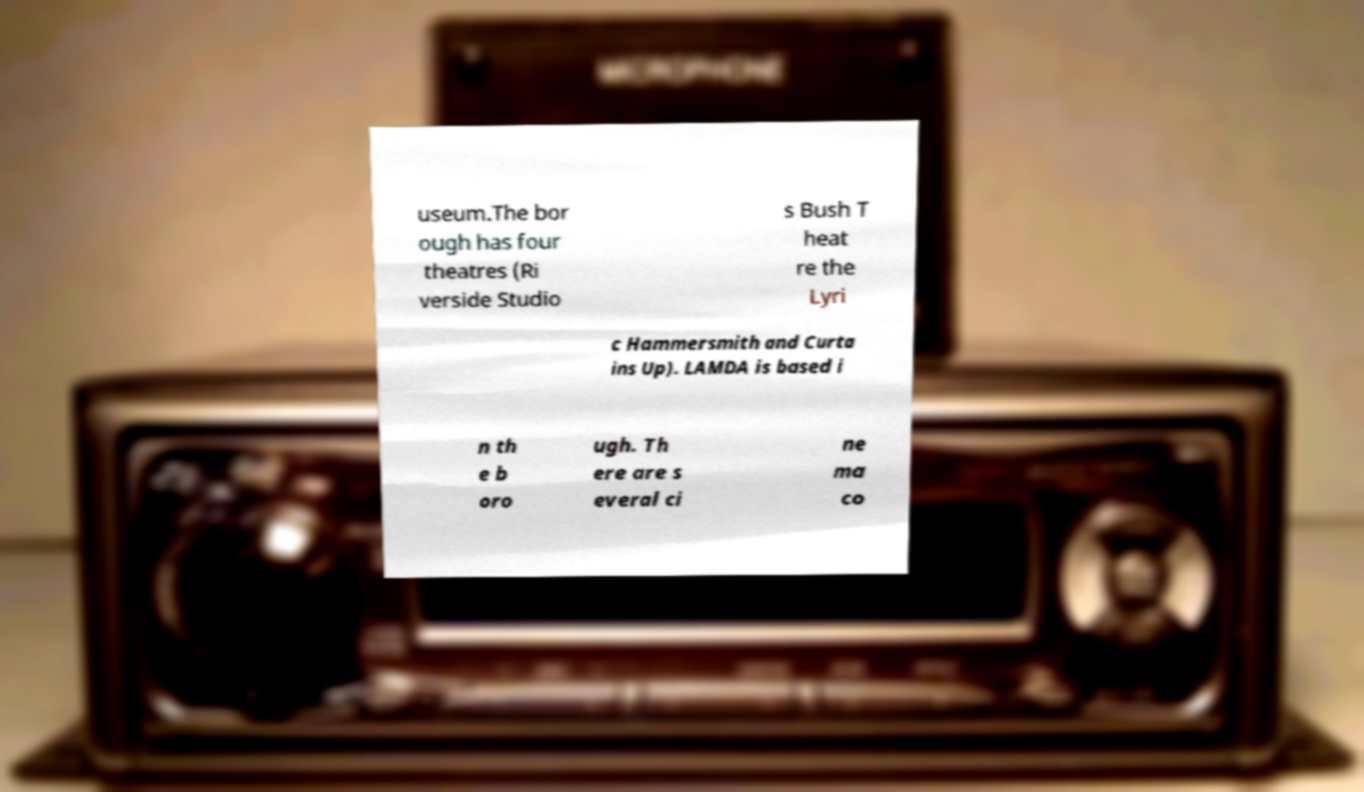There's text embedded in this image that I need extracted. Can you transcribe it verbatim? useum.The bor ough has four theatres (Ri verside Studio s Bush T heat re the Lyri c Hammersmith and Curta ins Up). LAMDA is based i n th e b oro ugh. Th ere are s everal ci ne ma co 